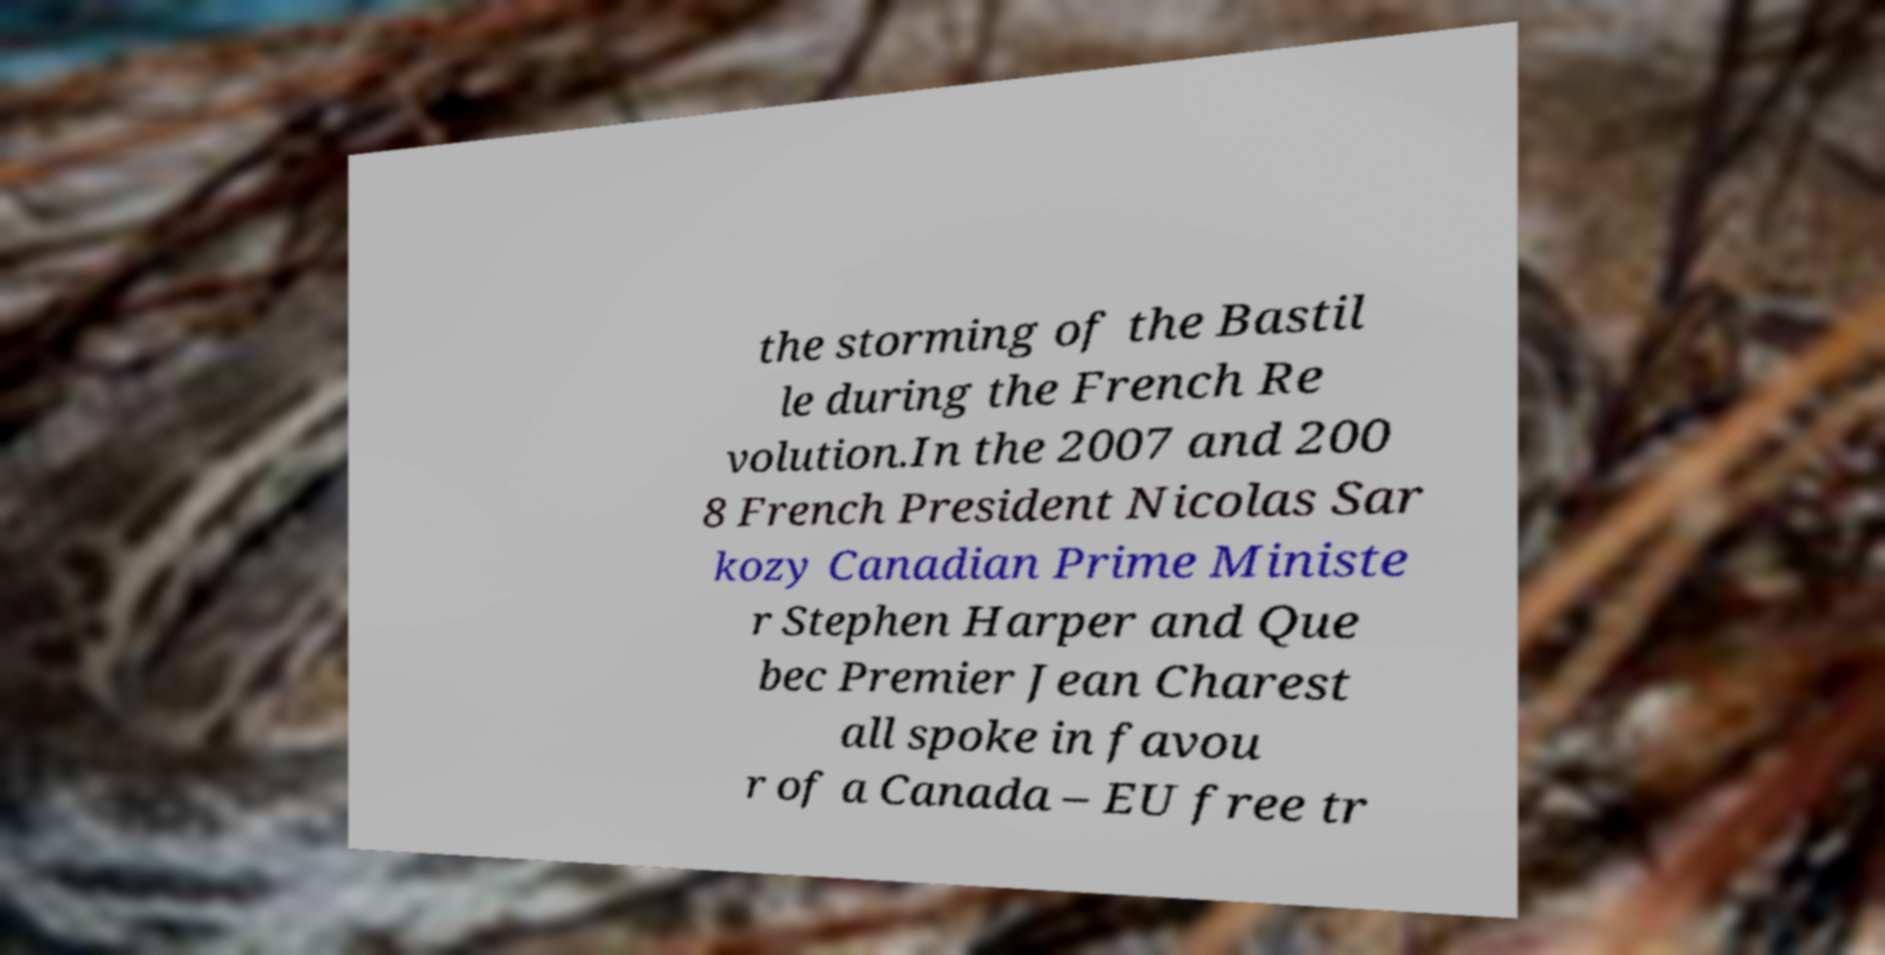For documentation purposes, I need the text within this image transcribed. Could you provide that? the storming of the Bastil le during the French Re volution.In the 2007 and 200 8 French President Nicolas Sar kozy Canadian Prime Ministe r Stephen Harper and Que bec Premier Jean Charest all spoke in favou r of a Canada – EU free tr 